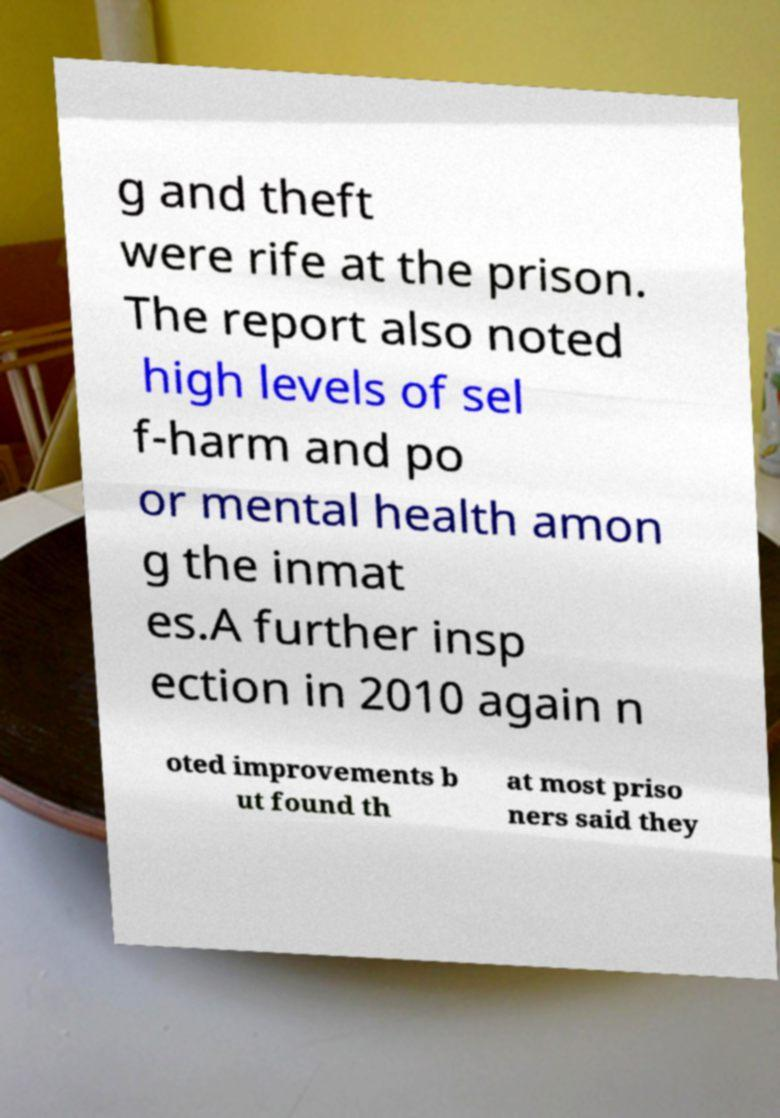I need the written content from this picture converted into text. Can you do that? g and theft were rife at the prison. The report also noted high levels of sel f-harm and po or mental health amon g the inmat es.A further insp ection in 2010 again n oted improvements b ut found th at most priso ners said they 